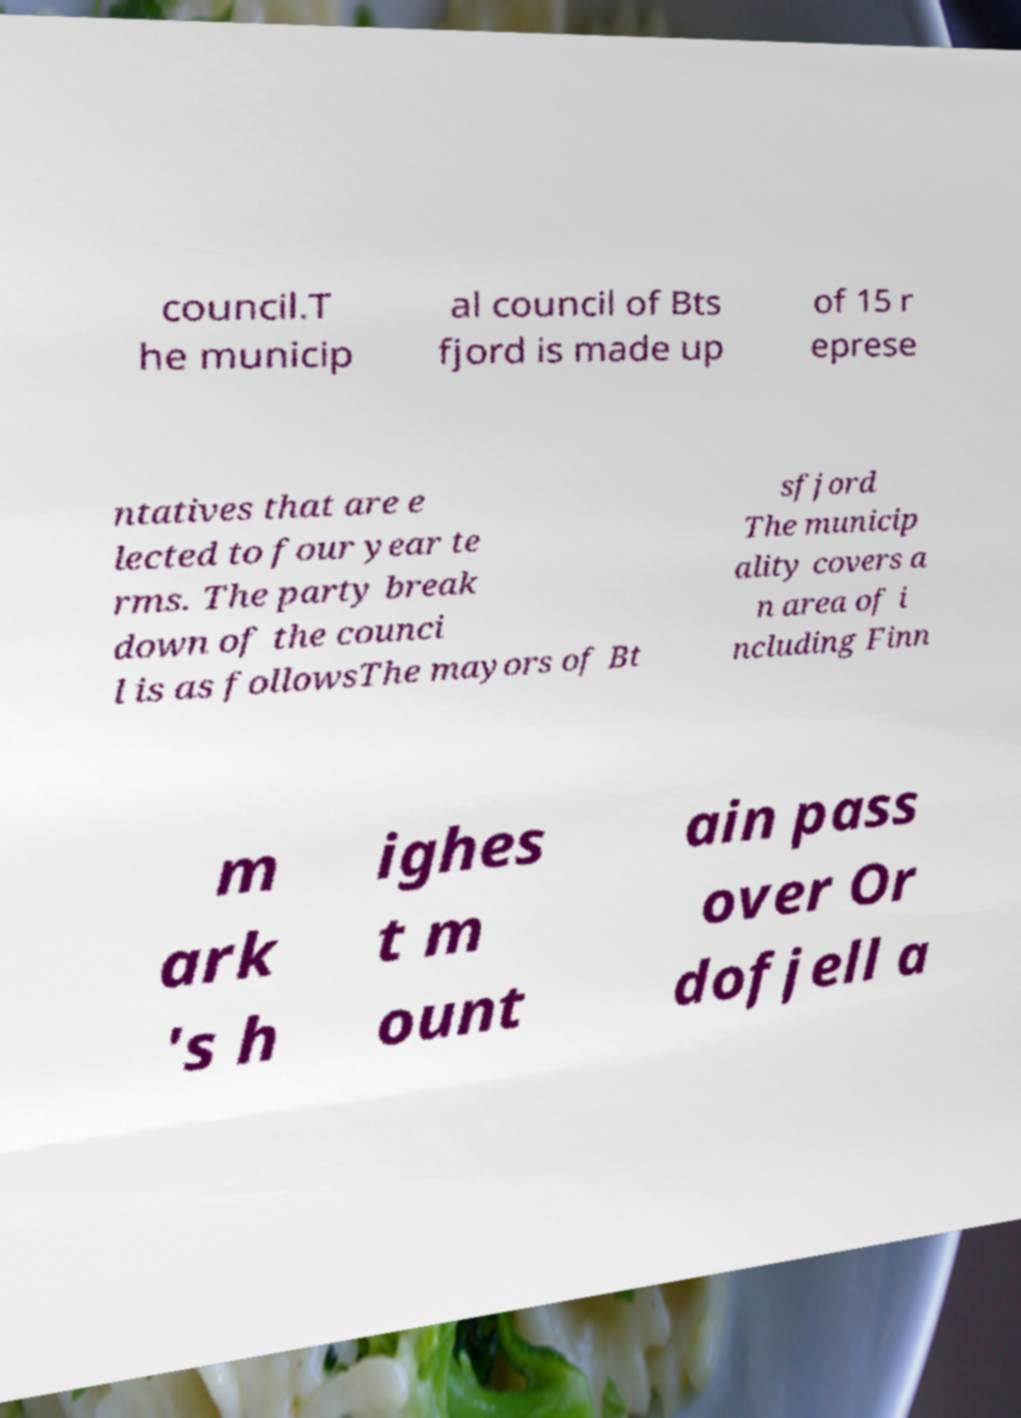Can you accurately transcribe the text from the provided image for me? council.T he municip al council of Bts fjord is made up of 15 r eprese ntatives that are e lected to four year te rms. The party break down of the counci l is as followsThe mayors of Bt sfjord The municip ality covers a n area of i ncluding Finn m ark 's h ighes t m ount ain pass over Or dofjell a 